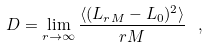<formula> <loc_0><loc_0><loc_500><loc_500>D = \lim _ { r \rightarrow \infty } \frac { \langle ( L _ { r M } - L _ { 0 } ) ^ { 2 } \rangle } { r M } \ ,</formula> 